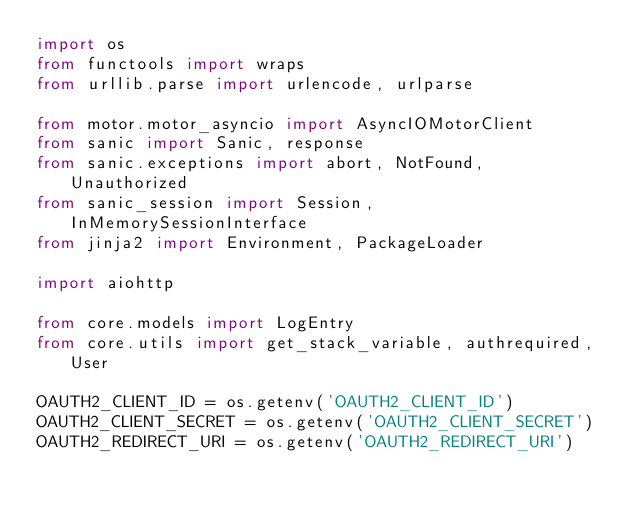Convert code to text. <code><loc_0><loc_0><loc_500><loc_500><_Python_>import os 
from functools import wraps
from urllib.parse import urlencode, urlparse

from motor.motor_asyncio import AsyncIOMotorClient
from sanic import Sanic, response
from sanic.exceptions import abort, NotFound, Unauthorized
from sanic_session import Session, InMemorySessionInterface
from jinja2 import Environment, PackageLoader

import aiohttp

from core.models import LogEntry
from core.utils import get_stack_variable, authrequired, User

OAUTH2_CLIENT_ID = os.getenv('OAUTH2_CLIENT_ID')
OAUTH2_CLIENT_SECRET = os.getenv('OAUTH2_CLIENT_SECRET')
OAUTH2_REDIRECT_URI = os.getenv('OAUTH2_REDIRECT_URI')
</code> 